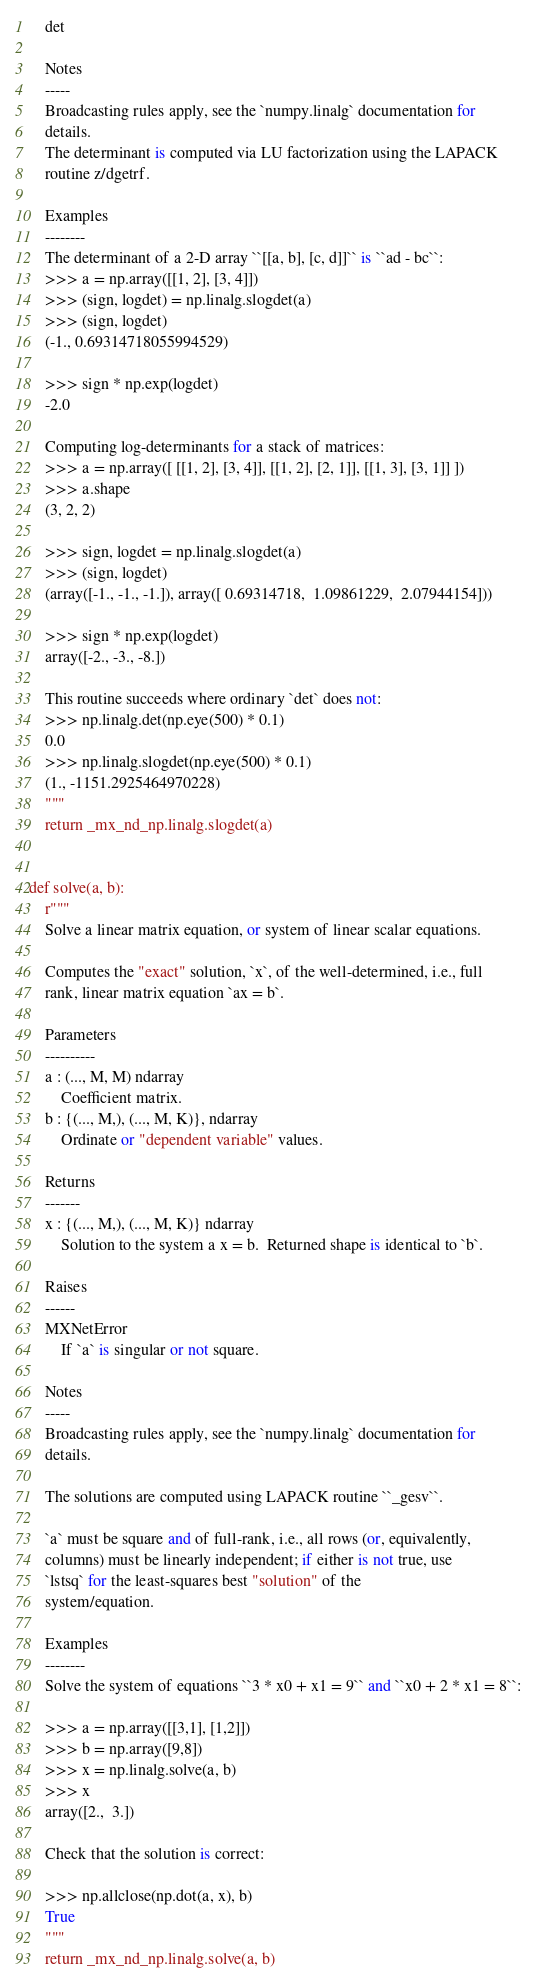Convert code to text. <code><loc_0><loc_0><loc_500><loc_500><_Python_>    det

    Notes
    -----
    Broadcasting rules apply, see the `numpy.linalg` documentation for
    details.
    The determinant is computed via LU factorization using the LAPACK
    routine z/dgetrf.

    Examples
    --------
    The determinant of a 2-D array ``[[a, b], [c, d]]`` is ``ad - bc``:
    >>> a = np.array([[1, 2], [3, 4]])
    >>> (sign, logdet) = np.linalg.slogdet(a)
    >>> (sign, logdet)
    (-1., 0.69314718055994529)

    >>> sign * np.exp(logdet)
    -2.0

    Computing log-determinants for a stack of matrices:
    >>> a = np.array([ [[1, 2], [3, 4]], [[1, 2], [2, 1]], [[1, 3], [3, 1]] ])
    >>> a.shape
    (3, 2, 2)

    >>> sign, logdet = np.linalg.slogdet(a)
    >>> (sign, logdet)
    (array([-1., -1., -1.]), array([ 0.69314718,  1.09861229,  2.07944154]))

    >>> sign * np.exp(logdet)
    array([-2., -3., -8.])

    This routine succeeds where ordinary `det` does not:
    >>> np.linalg.det(np.eye(500) * 0.1)
    0.0
    >>> np.linalg.slogdet(np.eye(500) * 0.1)
    (1., -1151.2925464970228)
    """
    return _mx_nd_np.linalg.slogdet(a)


def solve(a, b):
    r"""
    Solve a linear matrix equation, or system of linear scalar equations.

    Computes the "exact" solution, `x`, of the well-determined, i.e., full
    rank, linear matrix equation `ax = b`.

    Parameters
    ----------
    a : (..., M, M) ndarray
        Coefficient matrix.
    b : {(..., M,), (..., M, K)}, ndarray
        Ordinate or "dependent variable" values.

    Returns
    -------
    x : {(..., M,), (..., M, K)} ndarray
        Solution to the system a x = b.  Returned shape is identical to `b`.

    Raises
    ------
    MXNetError
        If `a` is singular or not square.

    Notes
    -----
    Broadcasting rules apply, see the `numpy.linalg` documentation for
    details.

    The solutions are computed using LAPACK routine ``_gesv``.

    `a` must be square and of full-rank, i.e., all rows (or, equivalently,
    columns) must be linearly independent; if either is not true, use
    `lstsq` for the least-squares best "solution" of the
    system/equation.

    Examples
    --------
    Solve the system of equations ``3 * x0 + x1 = 9`` and ``x0 + 2 * x1 = 8``:

    >>> a = np.array([[3,1], [1,2]])
    >>> b = np.array([9,8])
    >>> x = np.linalg.solve(a, b)
    >>> x
    array([2.,  3.])

    Check that the solution is correct:

    >>> np.allclose(np.dot(a, x), b)
    True
    """
    return _mx_nd_np.linalg.solve(a, b)
</code> 